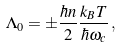<formula> <loc_0><loc_0><loc_500><loc_500>\Lambda _ { 0 } = \pm \frac { \hbar { n } } { 2 } \frac { k _ { B } T } { \hbar { \omega } _ { c } } \, ,</formula> 